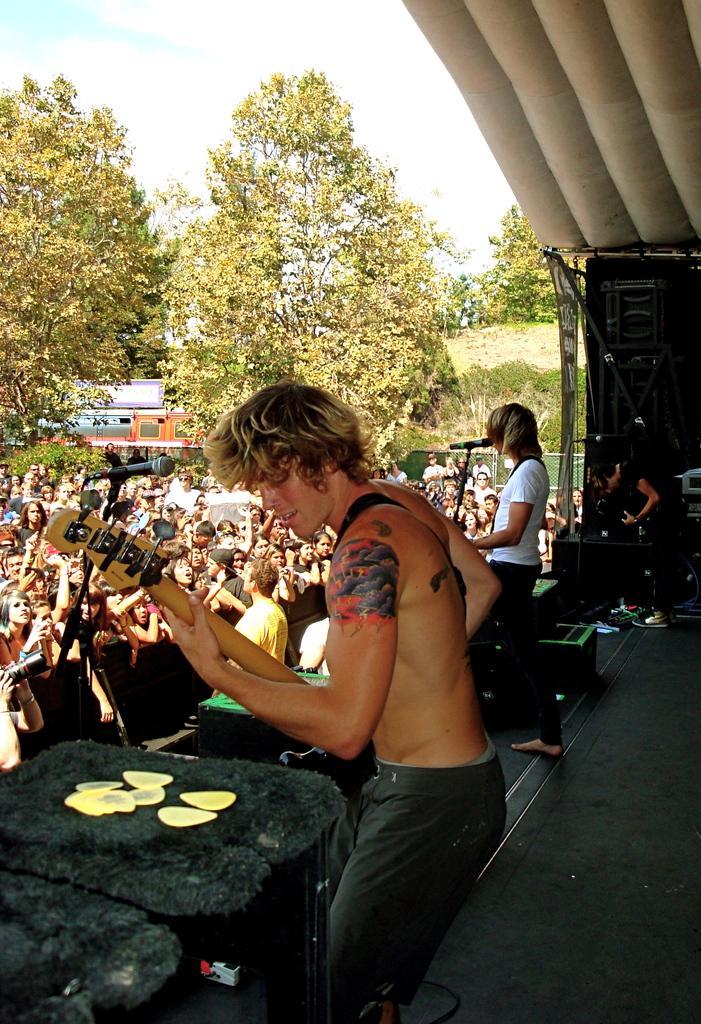Could you give a brief overview of what you see in this image? In the foreground of this image, on the stage, there are three persons playing guitar in front of mics. In the background, there is crowd standing, trees, few objects, sky and the cloud on the top. 